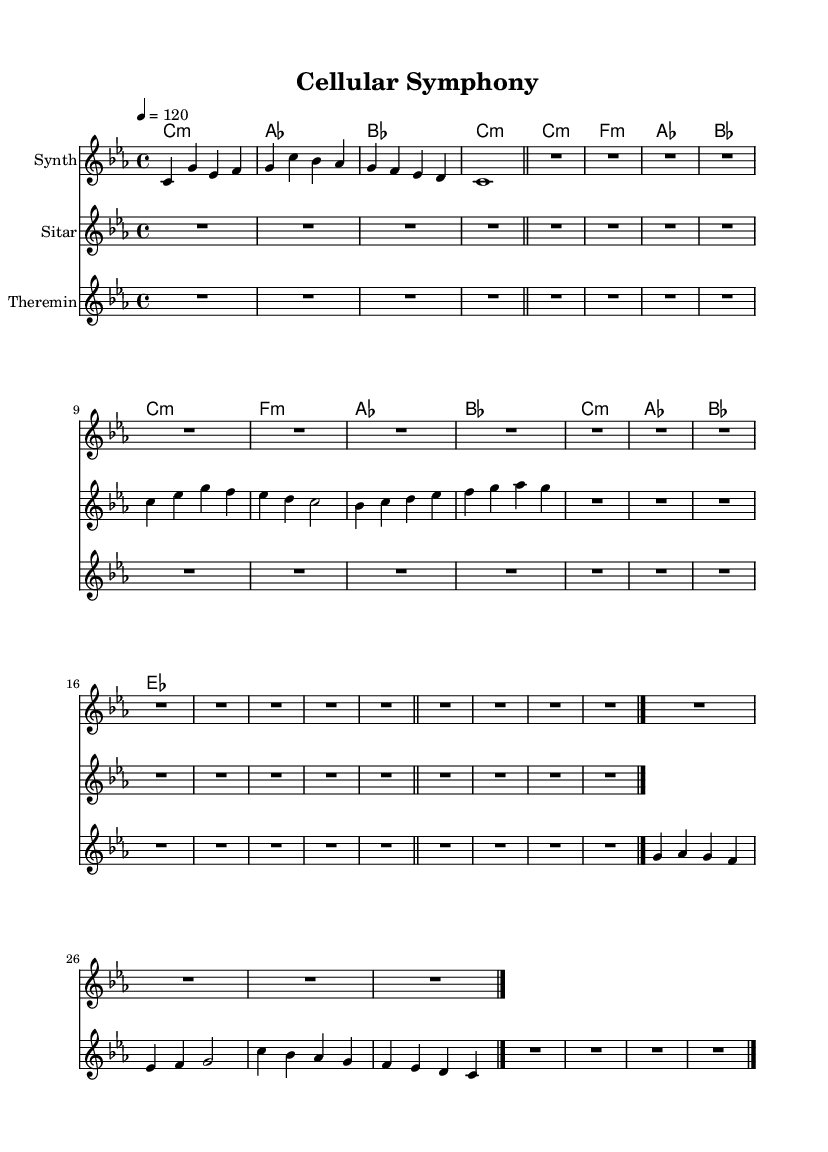What is the key signature of this music? The key signature shown is C minor, which is indicated by the three flats (B, E, and A) in the music.
Answer: C minor What is the time signature of this music? The time signature is 4/4, which is indicated at the beginning of the sheet music and shows that there are four beats in each measure.
Answer: 4/4 What is the tempo marking for this piece? The tempo marking is 120, indicated by the "4 = 120" statement, meaning there are 120 quarter-note beats per minute.
Answer: 120 Which instruments are featured in this composition? The instruments indicated in the sheet music are Synth, Sitar, and Theremin, as shown in the staff labels under each music part.
Answer: Synth, Sitar, Theremin How many measures does the synthesizer part contain? The synthesizer part contains a total of 5 measures, as counted from the notation shown in the staff.
Answer: 5 What is the dynamic marking for the sitar section? There is no specific dynamic marking indicated for the sitar section, thus suggesting a general dynamic level for performance.
Answer: None What is the overall theme or inspiration for this composition? This composition is inspired by microscopic imagery and laboratory sounds, which influences both its musical structure and electronic elements.
Answer: Microscopic imagery and laboratory sounds 